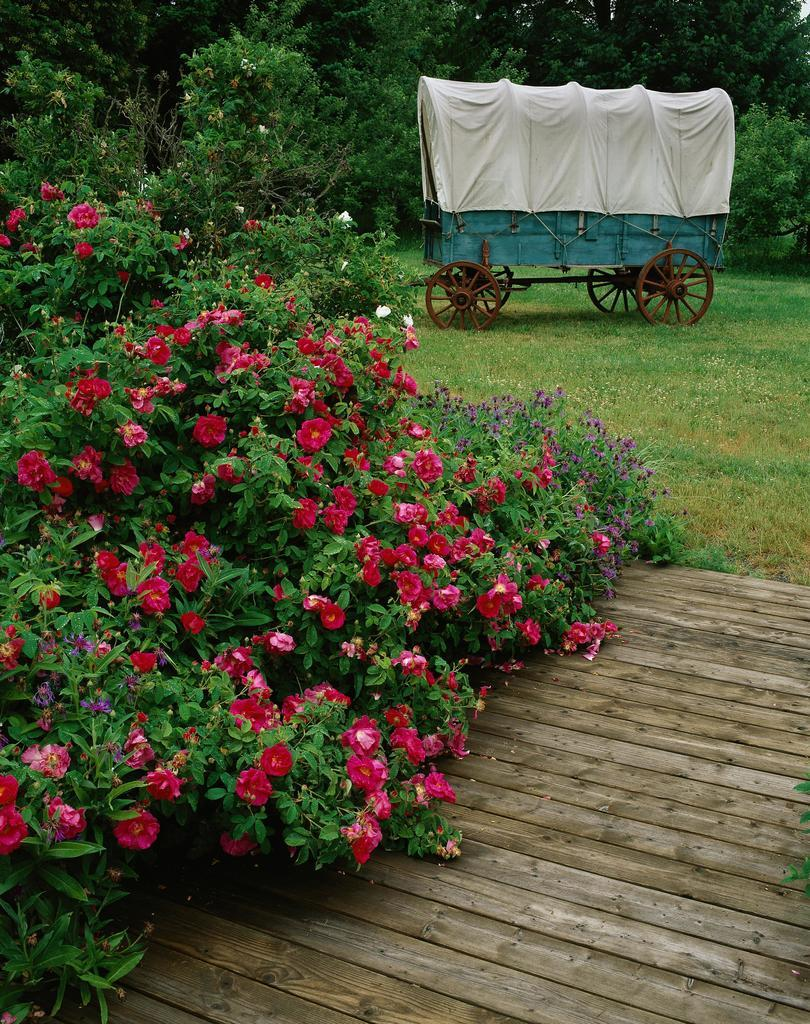What type of path is visible in the image? There is a wooden path in the image. What can be seen on the left side of the image? There are rose plants on the left side of the image. What is located in the background of the image? There is a cart and trees in the background of the image. How many forks can be seen in the image? There are no forks present in the image. What type of trains are visible in the image? There are no trains present in the image. 